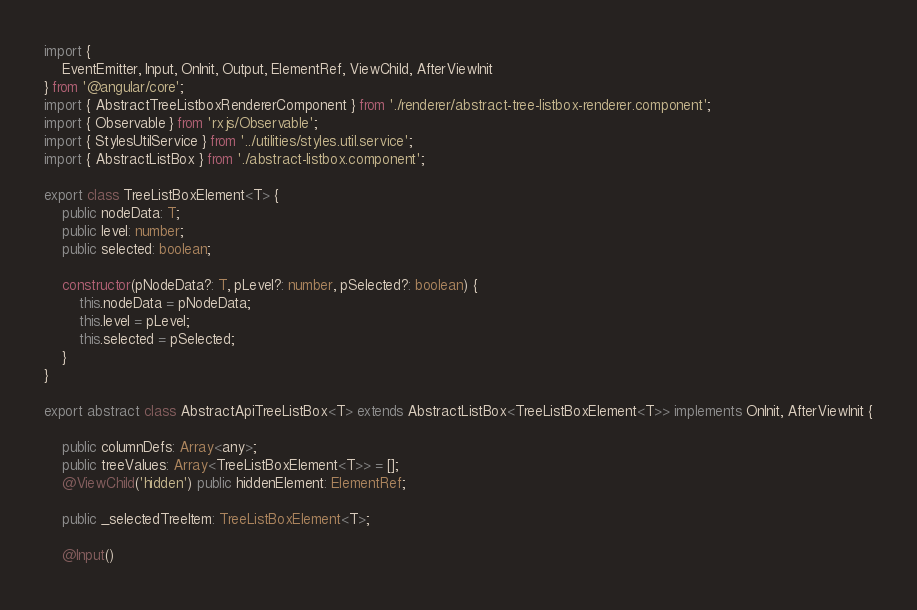<code> <loc_0><loc_0><loc_500><loc_500><_TypeScript_>import {
	EventEmitter, Input, OnInit, Output, ElementRef, ViewChild, AfterViewInit
} from '@angular/core';
import { AbstractTreeListboxRendererComponent } from './renderer/abstract-tree-listbox-renderer.component';
import { Observable } from 'rxjs/Observable';
import { StylesUtilService } from '../utilities/styles.util.service';
import { AbstractListBox } from './abstract-listbox.component';

export class TreeListBoxElement<T> {
	public nodeData: T;
	public level: number;
	public selected: boolean;

	constructor(pNodeData?: T, pLevel?: number, pSelected?: boolean) {
		this.nodeData = pNodeData;
		this.level = pLevel;
		this.selected = pSelected;
	}
}

export abstract class AbstractApiTreeListBox<T> extends AbstractListBox<TreeListBoxElement<T>> implements OnInit, AfterViewInit {

	public columnDefs: Array<any>;
	public treeValues: Array<TreeListBoxElement<T>> = [];
	@ViewChild('hidden') public hiddenElement: ElementRef;

	public _selectedTreeItem: TreeListBoxElement<T>;

	@Input()</code> 